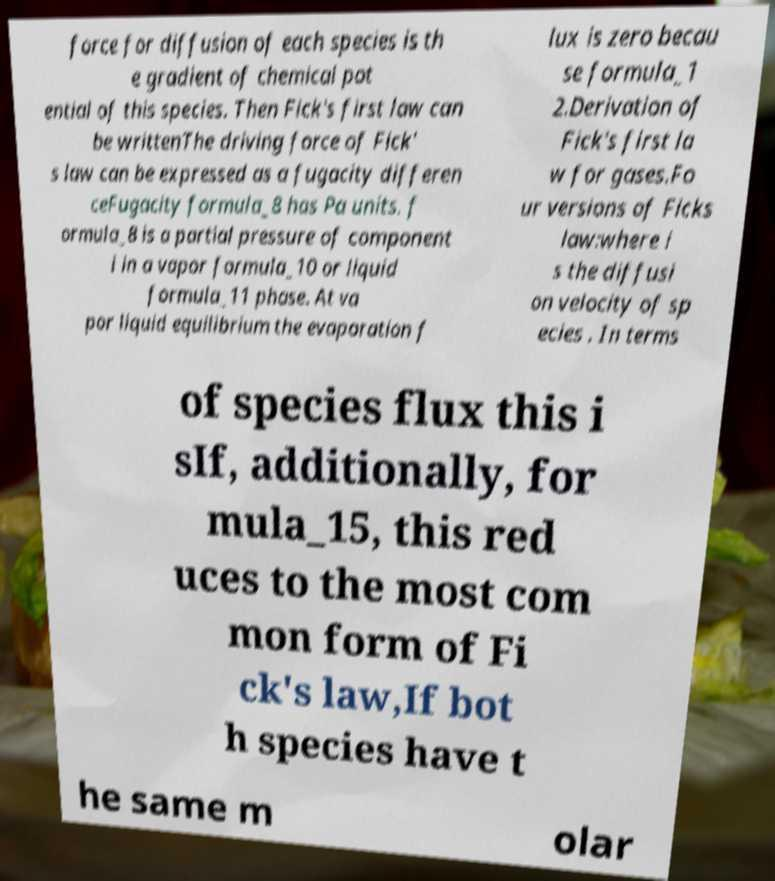Can you read and provide the text displayed in the image?This photo seems to have some interesting text. Can you extract and type it out for me? force for diffusion of each species is th e gradient of chemical pot ential of this species. Then Fick's first law can be writtenThe driving force of Fick' s law can be expressed as a fugacity differen ceFugacity formula_8 has Pa units. f ormula_8 is a partial pressure of component i in a vapor formula_10 or liquid formula_11 phase. At va por liquid equilibrium the evaporation f lux is zero becau se formula_1 2.Derivation of Fick's first la w for gases.Fo ur versions of Ficks law:where i s the diffusi on velocity of sp ecies . In terms of species flux this i sIf, additionally, for mula_15, this red uces to the most com mon form of Fi ck's law,If bot h species have t he same m olar 